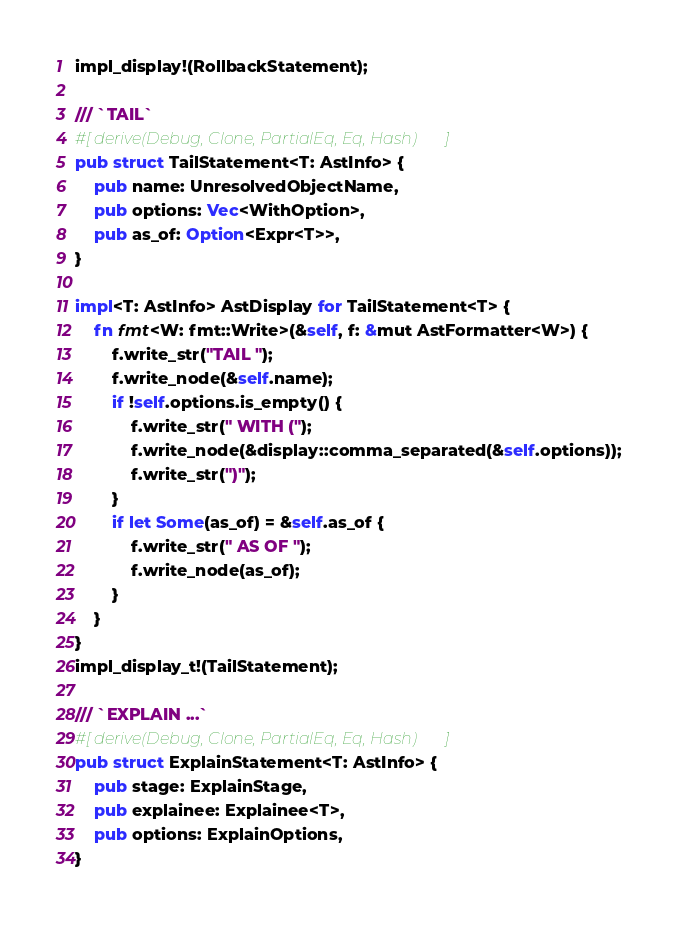Convert code to text. <code><loc_0><loc_0><loc_500><loc_500><_Rust_>impl_display!(RollbackStatement);

/// `TAIL`
#[derive(Debug, Clone, PartialEq, Eq, Hash)]
pub struct TailStatement<T: AstInfo> {
    pub name: UnresolvedObjectName,
    pub options: Vec<WithOption>,
    pub as_of: Option<Expr<T>>,
}

impl<T: AstInfo> AstDisplay for TailStatement<T> {
    fn fmt<W: fmt::Write>(&self, f: &mut AstFormatter<W>) {
        f.write_str("TAIL ");
        f.write_node(&self.name);
        if !self.options.is_empty() {
            f.write_str(" WITH (");
            f.write_node(&display::comma_separated(&self.options));
            f.write_str(")");
        }
        if let Some(as_of) = &self.as_of {
            f.write_str(" AS OF ");
            f.write_node(as_of);
        }
    }
}
impl_display_t!(TailStatement);

/// `EXPLAIN ...`
#[derive(Debug, Clone, PartialEq, Eq, Hash)]
pub struct ExplainStatement<T: AstInfo> {
    pub stage: ExplainStage,
    pub explainee: Explainee<T>,
    pub options: ExplainOptions,
}
</code> 